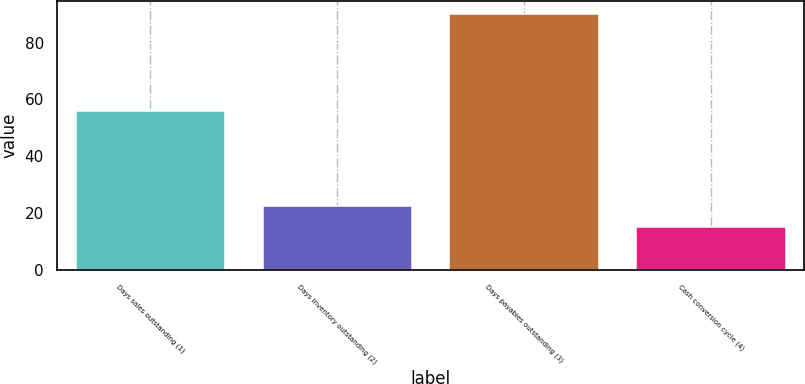Convert chart. <chart><loc_0><loc_0><loc_500><loc_500><bar_chart><fcel>Days sales outstanding (1)<fcel>Days inventory outstanding (2)<fcel>Days payables outstanding (3)<fcel>Cash conversion cycle (4)<nl><fcel>56<fcel>22.5<fcel>90<fcel>15<nl></chart> 